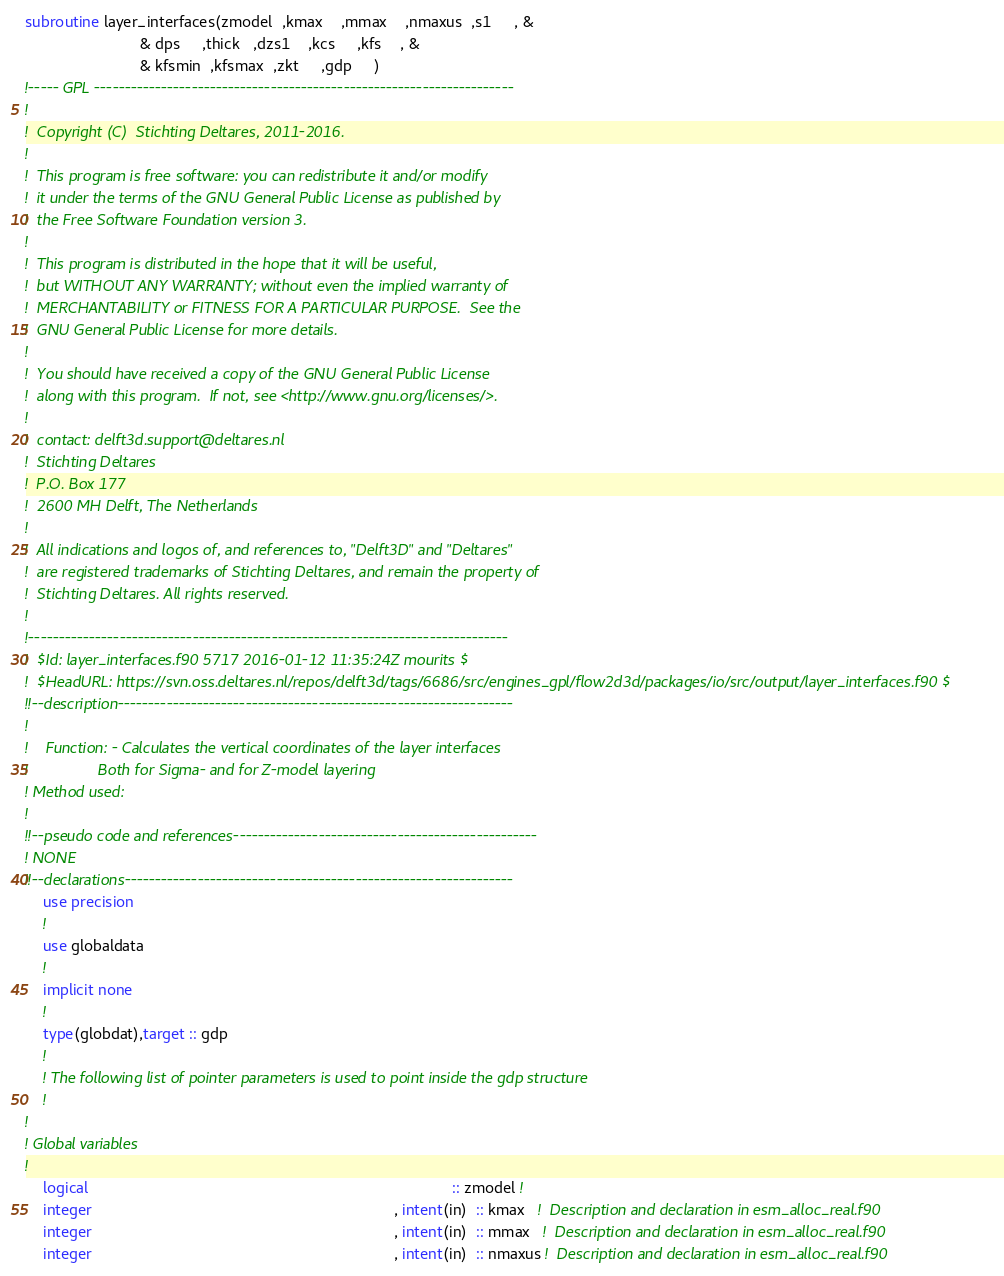Convert code to text. <code><loc_0><loc_0><loc_500><loc_500><_FORTRAN_>subroutine layer_interfaces(zmodel  ,kmax    ,mmax    ,nmaxus  ,s1     , &
                          & dps     ,thick   ,dzs1    ,kcs     ,kfs    , &
                          & kfsmin  ,kfsmax  ,zkt     ,gdp     )
!----- GPL ---------------------------------------------------------------------
!                                                                               
!  Copyright (C)  Stichting Deltares, 2011-2016.                                
!                                                                               
!  This program is free software: you can redistribute it and/or modify         
!  it under the terms of the GNU General Public License as published by         
!  the Free Software Foundation version 3.                                      
!                                                                               
!  This program is distributed in the hope that it will be useful,              
!  but WITHOUT ANY WARRANTY; without even the implied warranty of               
!  MERCHANTABILITY or FITNESS FOR A PARTICULAR PURPOSE.  See the                
!  GNU General Public License for more details.                                 
!                                                                               
!  You should have received a copy of the GNU General Public License            
!  along with this program.  If not, see <http://www.gnu.org/licenses/>.        
!                                                                               
!  contact: delft3d.support@deltares.nl                                         
!  Stichting Deltares                                                           
!  P.O. Box 177                                                                 
!  2600 MH Delft, The Netherlands                                               
!                                                                               
!  All indications and logos of, and references to, "Delft3D" and "Deltares"    
!  are registered trademarks of Stichting Deltares, and remain the property of  
!  Stichting Deltares. All rights reserved.                                     
!                                                                               
!-------------------------------------------------------------------------------
!  $Id: layer_interfaces.f90 5717 2016-01-12 11:35:24Z mourits $
!  $HeadURL: https://svn.oss.deltares.nl/repos/delft3d/tags/6686/src/engines_gpl/flow2d3d/packages/io/src/output/layer_interfaces.f90 $
!!--description-----------------------------------------------------------------
!
!    Function: - Calculates the vertical coordinates of the layer interfaces
!                Both for Sigma- and for Z-model layering
! Method used:
!
!!--pseudo code and references--------------------------------------------------
! NONE
!!--declarations----------------------------------------------------------------
    use precision
    !
    use globaldata
    !
    implicit none
    !
    type(globdat),target :: gdp
    !
    ! The following list of pointer parameters is used to point inside the gdp structure
    !
!
! Global variables
!
    logical                                                                                   :: zmodel !  
    integer                                                                     , intent(in)  :: kmax   !  Description and declaration in esm_alloc_real.f90
    integer                                                                     , intent(in)  :: mmax   !  Description and declaration in esm_alloc_real.f90
    integer                                                                     , intent(in)  :: nmaxus !  Description and declaration in esm_alloc_real.f90</code> 